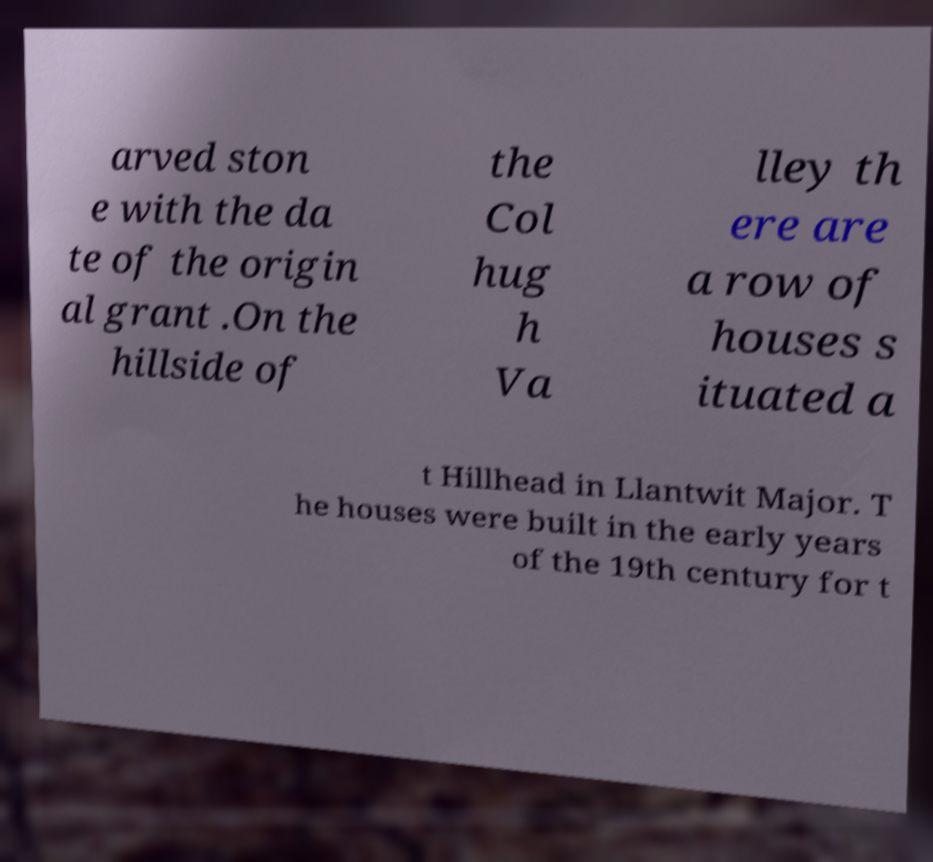What messages or text are displayed in this image? I need them in a readable, typed format. arved ston e with the da te of the origin al grant .On the hillside of the Col hug h Va lley th ere are a row of houses s ituated a t Hillhead in Llantwit Major. T he houses were built in the early years of the 19th century for t 